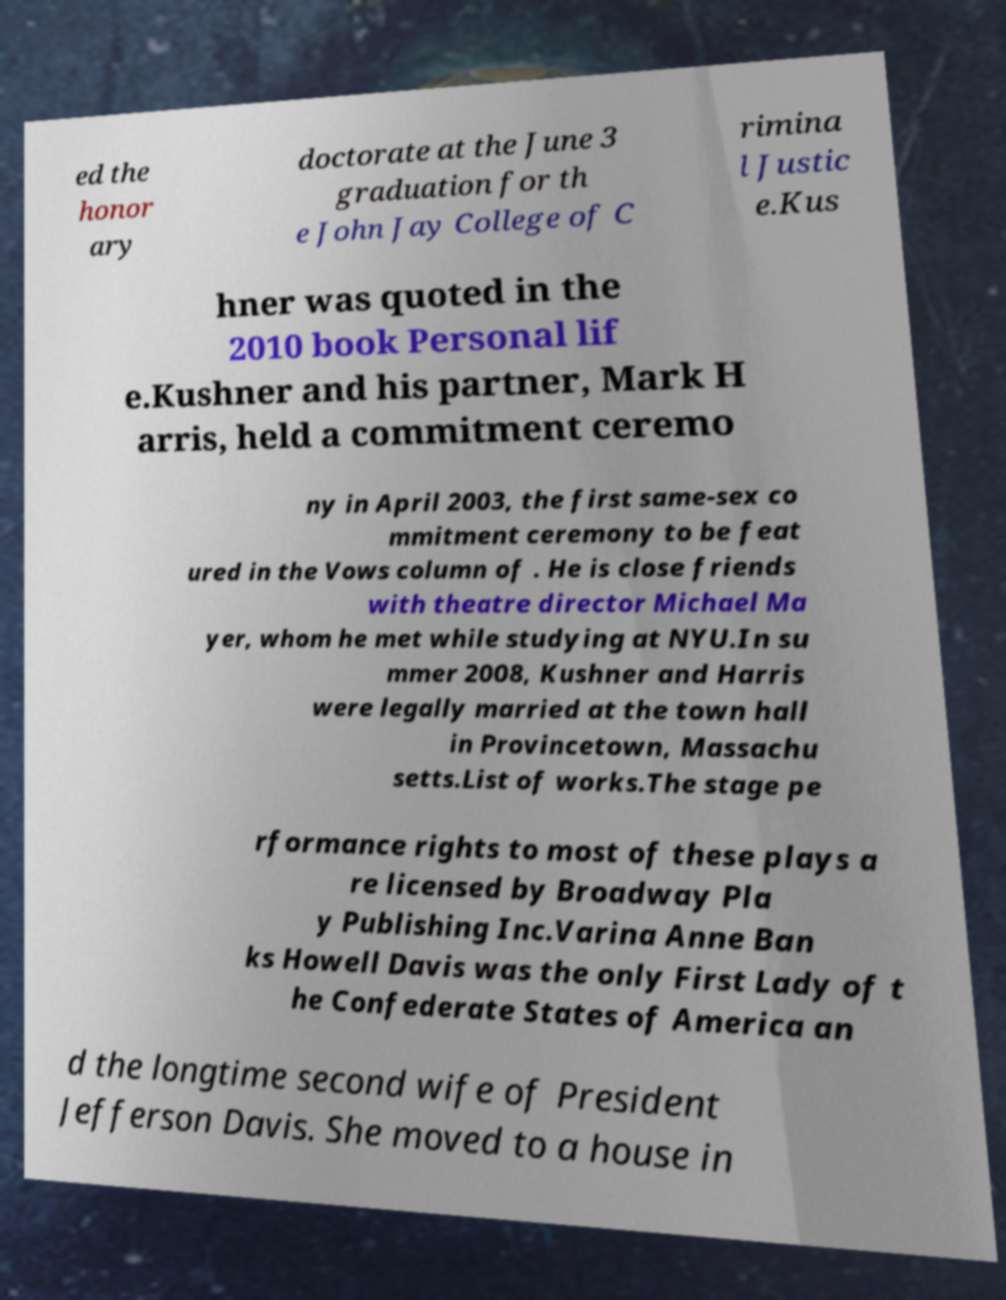Please read and relay the text visible in this image. What does it say? ed the honor ary doctorate at the June 3 graduation for th e John Jay College of C rimina l Justic e.Kus hner was quoted in the 2010 book Personal lif e.Kushner and his partner, Mark H arris, held a commitment ceremo ny in April 2003, the first same-sex co mmitment ceremony to be feat ured in the Vows column of . He is close friends with theatre director Michael Ma yer, whom he met while studying at NYU.In su mmer 2008, Kushner and Harris were legally married at the town hall in Provincetown, Massachu setts.List of works.The stage pe rformance rights to most of these plays a re licensed by Broadway Pla y Publishing Inc.Varina Anne Ban ks Howell Davis was the only First Lady of t he Confederate States of America an d the longtime second wife of President Jefferson Davis. She moved to a house in 